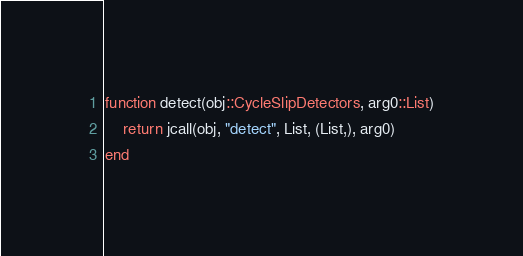Convert code to text. <code><loc_0><loc_0><loc_500><loc_500><_Julia_>function detect(obj::CycleSlipDetectors, arg0::List)
    return jcall(obj, "detect", List, (List,), arg0)
end

</code> 